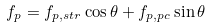Convert formula to latex. <formula><loc_0><loc_0><loc_500><loc_500>f _ { p } = f _ { p , s t r } \cos \theta + f _ { p , p c } \sin \theta</formula> 